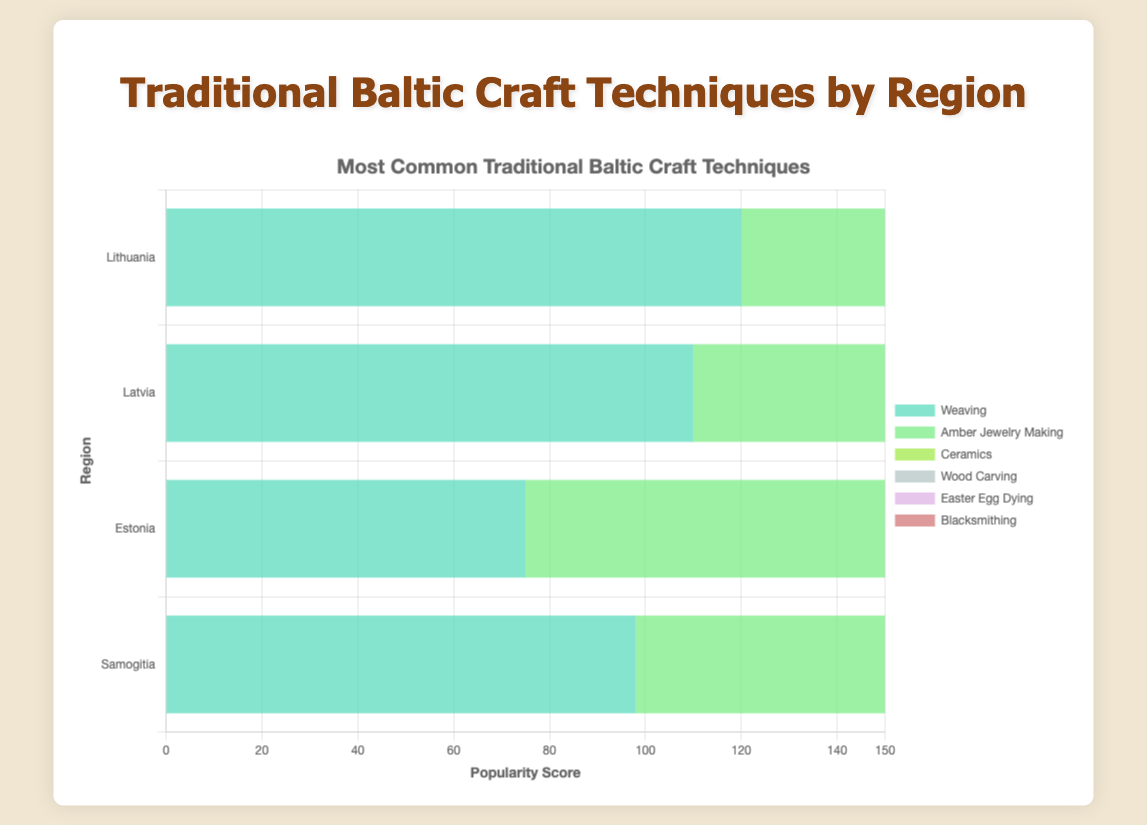Which region has the highest popularity score for Weaving? The length of the bar for Weaving is the longest for the region Lithuania when compared to other regions.
Answer: Lithuania Which craft technique is the least popular in Samogitia? Among all the craft techniques listed for Samogitia, the bar representing Easter Egg Dying is the shortest.
Answer: Easter Egg Dying Compare the popularity scores of Knitting in Latvia and Estonia. Which region has a higher score? By comparing the lengths of the bars for Knitting in Latvia and Estonia, the bar for Estonia is longer.
Answer: Estonia What's the sum of the popularity scores of Amber Jewelry Making across all regions? Calculate the total popularity score by summing Amber Jewelry Making scores from Lithuania (95), Latvia (98), Estonia (77), and Samogitia (85). So, 95 + 98 + 77 + 85 = 355
Answer: 355 Which two craft techniques have the closest popularity scores in Lithuania? In Lithuania, the popularity scores of Ceramics and Wood Carving are close to each other, with values of 80 and 65, respectively.
Answer: Ceramics and Wood Carving Which region has the widest variety of craft techniques? By examining the number of distinct craft techniques listed, both Lithuania and Latvia show six distinct techniques, compared to fewer for Estonia and Samogitia.
Answer: Lithuania and Latvia What is the average popularity score for Wood Carving across all four regions? Calculate the average by summing the scores of Wood Carving from Lithuania (65), Latvia (70), Estonia (85), and Samogitia (88), then dividing by 4. So, (65 + 70 + 85 + 88) / 4 = 77
Answer: 77 Is Amber Jewelry Making more popular in Latvia or Estonia? Comparing the lengths of the bars for Amber Jewelry Making, Latvia has a longer bar than Estonia.
Answer: Latvia Which craft technique is the most popular in Estonia? The longest bar in Estonia corresponds to Knitting.
Answer: Knitting What is the difference in popularity scores for Weaving between Lithuania and Samogitia? Subtract the Weaving score in Samogitia (98) from the score in Lithuania (120). So, 120 - 98 = 22
Answer: 22 